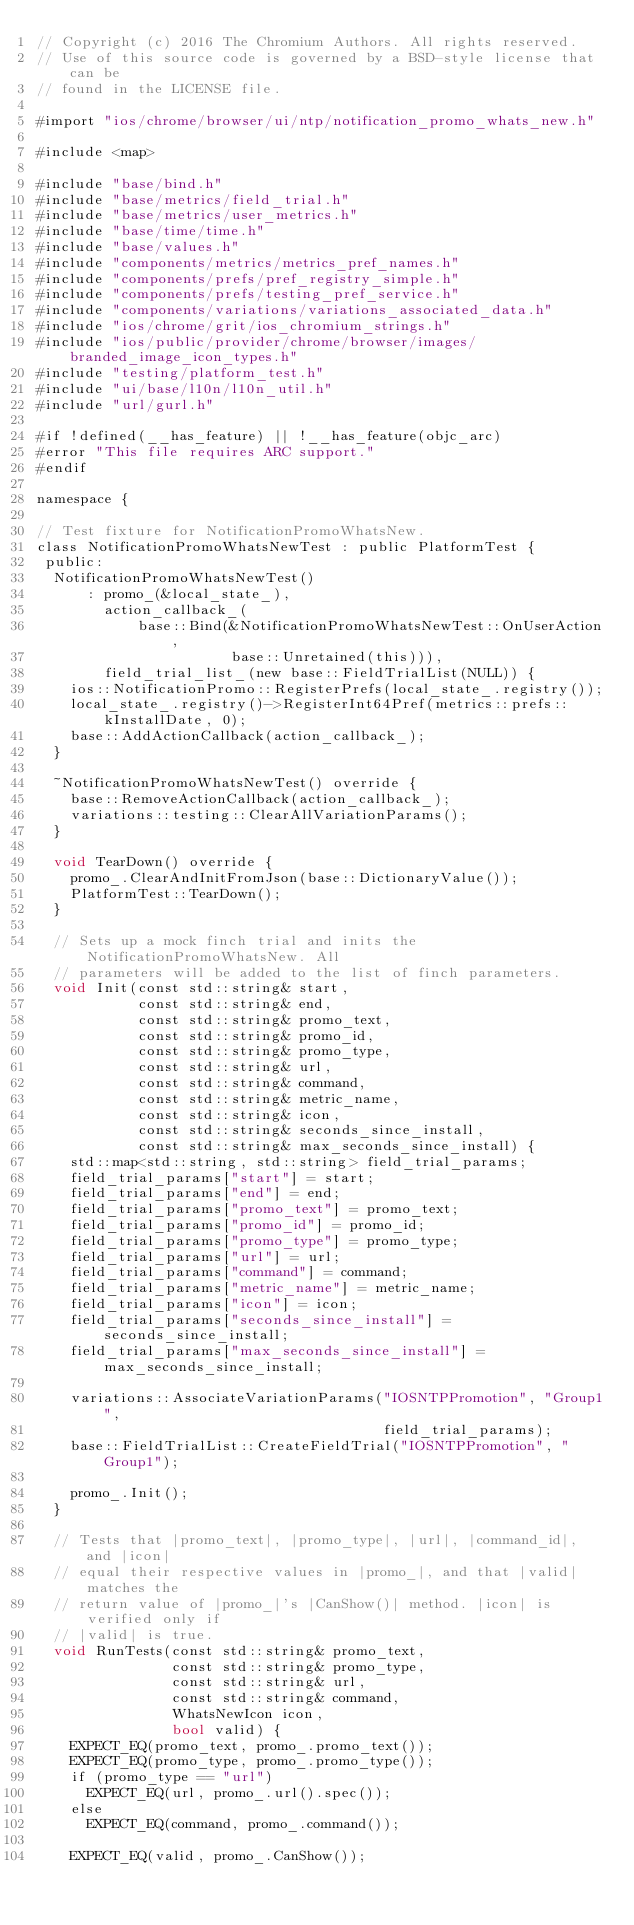<code> <loc_0><loc_0><loc_500><loc_500><_ObjectiveC_>// Copyright (c) 2016 The Chromium Authors. All rights reserved.
// Use of this source code is governed by a BSD-style license that can be
// found in the LICENSE file.

#import "ios/chrome/browser/ui/ntp/notification_promo_whats_new.h"

#include <map>

#include "base/bind.h"
#include "base/metrics/field_trial.h"
#include "base/metrics/user_metrics.h"
#include "base/time/time.h"
#include "base/values.h"
#include "components/metrics/metrics_pref_names.h"
#include "components/prefs/pref_registry_simple.h"
#include "components/prefs/testing_pref_service.h"
#include "components/variations/variations_associated_data.h"
#include "ios/chrome/grit/ios_chromium_strings.h"
#include "ios/public/provider/chrome/browser/images/branded_image_icon_types.h"
#include "testing/platform_test.h"
#include "ui/base/l10n/l10n_util.h"
#include "url/gurl.h"

#if !defined(__has_feature) || !__has_feature(objc_arc)
#error "This file requires ARC support."
#endif

namespace {

// Test fixture for NotificationPromoWhatsNew.
class NotificationPromoWhatsNewTest : public PlatformTest {
 public:
  NotificationPromoWhatsNewTest()
      : promo_(&local_state_),
        action_callback_(
            base::Bind(&NotificationPromoWhatsNewTest::OnUserAction,
                       base::Unretained(this))),
        field_trial_list_(new base::FieldTrialList(NULL)) {
    ios::NotificationPromo::RegisterPrefs(local_state_.registry());
    local_state_.registry()->RegisterInt64Pref(metrics::prefs::kInstallDate, 0);
    base::AddActionCallback(action_callback_);
  }

  ~NotificationPromoWhatsNewTest() override {
    base::RemoveActionCallback(action_callback_);
    variations::testing::ClearAllVariationParams();
  }

  void TearDown() override {
    promo_.ClearAndInitFromJson(base::DictionaryValue());
    PlatformTest::TearDown();
  }

  // Sets up a mock finch trial and inits the NotificationPromoWhatsNew. All
  // parameters will be added to the list of finch parameters.
  void Init(const std::string& start,
            const std::string& end,
            const std::string& promo_text,
            const std::string& promo_id,
            const std::string& promo_type,
            const std::string& url,
            const std::string& command,
            const std::string& metric_name,
            const std::string& icon,
            const std::string& seconds_since_install,
            const std::string& max_seconds_since_install) {
    std::map<std::string, std::string> field_trial_params;
    field_trial_params["start"] = start;
    field_trial_params["end"] = end;
    field_trial_params["promo_text"] = promo_text;
    field_trial_params["promo_id"] = promo_id;
    field_trial_params["promo_type"] = promo_type;
    field_trial_params["url"] = url;
    field_trial_params["command"] = command;
    field_trial_params["metric_name"] = metric_name;
    field_trial_params["icon"] = icon;
    field_trial_params["seconds_since_install"] = seconds_since_install;
    field_trial_params["max_seconds_since_install"] = max_seconds_since_install;

    variations::AssociateVariationParams("IOSNTPPromotion", "Group1",
                                         field_trial_params);
    base::FieldTrialList::CreateFieldTrial("IOSNTPPromotion", "Group1");

    promo_.Init();
  }

  // Tests that |promo_text|, |promo_type|, |url|, |command_id|, and |icon|
  // equal their respective values in |promo_|, and that |valid| matches the
  // return value of |promo_|'s |CanShow()| method. |icon| is verified only if
  // |valid| is true.
  void RunTests(const std::string& promo_text,
                const std::string& promo_type,
                const std::string& url,
                const std::string& command,
                WhatsNewIcon icon,
                bool valid) {
    EXPECT_EQ(promo_text, promo_.promo_text());
    EXPECT_EQ(promo_type, promo_.promo_type());
    if (promo_type == "url")
      EXPECT_EQ(url, promo_.url().spec());
    else
      EXPECT_EQ(command, promo_.command());

    EXPECT_EQ(valid, promo_.CanShow());</code> 